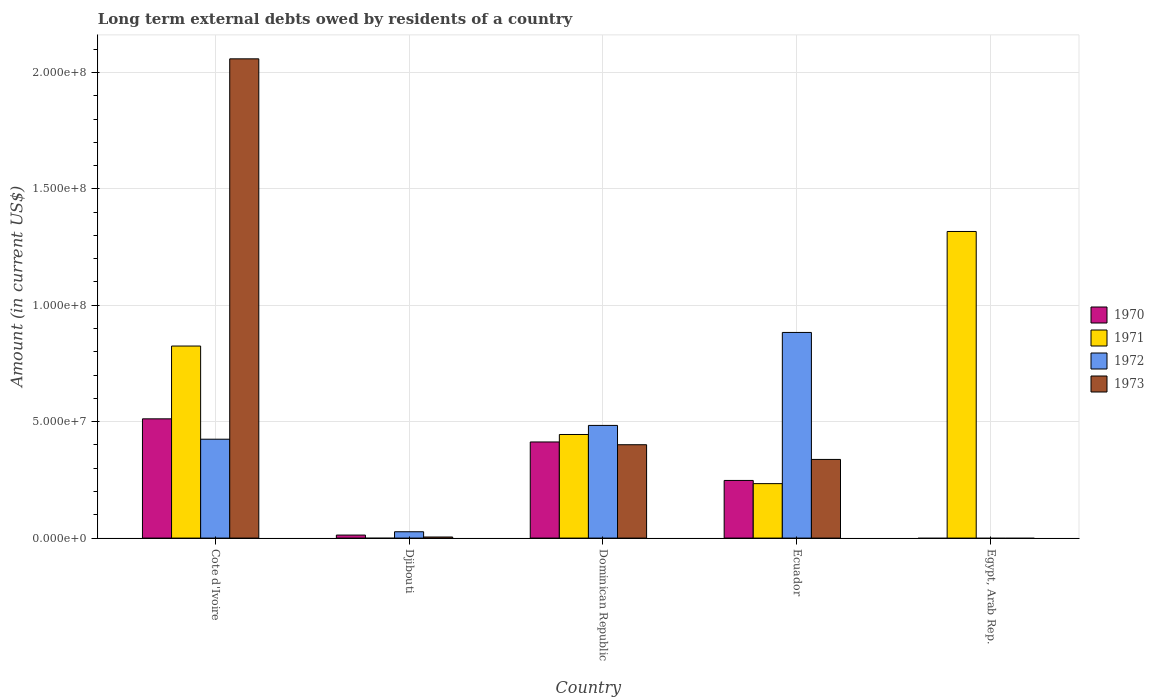Are the number of bars on each tick of the X-axis equal?
Provide a succinct answer. No. How many bars are there on the 4th tick from the left?
Your answer should be compact. 4. How many bars are there on the 5th tick from the right?
Offer a terse response. 4. What is the label of the 4th group of bars from the left?
Your answer should be compact. Ecuador. What is the amount of long-term external debts owed by residents in 1970 in Egypt, Arab Rep.?
Make the answer very short. 0. Across all countries, what is the maximum amount of long-term external debts owed by residents in 1970?
Offer a terse response. 5.12e+07. In which country was the amount of long-term external debts owed by residents in 1971 maximum?
Offer a very short reply. Egypt, Arab Rep. What is the total amount of long-term external debts owed by residents in 1973 in the graph?
Offer a terse response. 2.80e+08. What is the difference between the amount of long-term external debts owed by residents in 1972 in Dominican Republic and that in Ecuador?
Ensure brevity in your answer.  -3.99e+07. What is the difference between the amount of long-term external debts owed by residents in 1973 in Dominican Republic and the amount of long-term external debts owed by residents in 1971 in Cote d'Ivoire?
Ensure brevity in your answer.  -4.24e+07. What is the average amount of long-term external debts owed by residents in 1970 per country?
Offer a very short reply. 2.37e+07. What is the difference between the amount of long-term external debts owed by residents of/in 1970 and amount of long-term external debts owed by residents of/in 1972 in Ecuador?
Make the answer very short. -6.36e+07. In how many countries, is the amount of long-term external debts owed by residents in 1971 greater than 50000000 US$?
Your answer should be compact. 2. What is the ratio of the amount of long-term external debts owed by residents in 1970 in Cote d'Ivoire to that in Dominican Republic?
Keep it short and to the point. 1.24. Is the amount of long-term external debts owed by residents in 1970 in Cote d'Ivoire less than that in Djibouti?
Offer a terse response. No. Is the difference between the amount of long-term external debts owed by residents in 1970 in Djibouti and Ecuador greater than the difference between the amount of long-term external debts owed by residents in 1972 in Djibouti and Ecuador?
Keep it short and to the point. Yes. What is the difference between the highest and the second highest amount of long-term external debts owed by residents in 1970?
Ensure brevity in your answer.  9.93e+06. What is the difference between the highest and the lowest amount of long-term external debts owed by residents in 1973?
Your response must be concise. 2.06e+08. Is the sum of the amount of long-term external debts owed by residents in 1972 in Cote d'Ivoire and Ecuador greater than the maximum amount of long-term external debts owed by residents in 1970 across all countries?
Keep it short and to the point. Yes. Is it the case that in every country, the sum of the amount of long-term external debts owed by residents in 1973 and amount of long-term external debts owed by residents in 1972 is greater than the sum of amount of long-term external debts owed by residents in 1971 and amount of long-term external debts owed by residents in 1970?
Provide a short and direct response. No. What is the difference between two consecutive major ticks on the Y-axis?
Keep it short and to the point. 5.00e+07. Does the graph contain any zero values?
Your response must be concise. Yes. Does the graph contain grids?
Provide a succinct answer. Yes. How are the legend labels stacked?
Offer a terse response. Vertical. What is the title of the graph?
Your answer should be compact. Long term external debts owed by residents of a country. Does "1969" appear as one of the legend labels in the graph?
Your response must be concise. No. What is the label or title of the X-axis?
Your answer should be very brief. Country. What is the Amount (in current US$) of 1970 in Cote d'Ivoire?
Make the answer very short. 5.12e+07. What is the Amount (in current US$) of 1971 in Cote d'Ivoire?
Your response must be concise. 8.25e+07. What is the Amount (in current US$) of 1972 in Cote d'Ivoire?
Your answer should be very brief. 4.25e+07. What is the Amount (in current US$) of 1973 in Cote d'Ivoire?
Provide a short and direct response. 2.06e+08. What is the Amount (in current US$) of 1970 in Djibouti?
Offer a terse response. 1.30e+06. What is the Amount (in current US$) of 1971 in Djibouti?
Give a very brief answer. 0. What is the Amount (in current US$) of 1972 in Djibouti?
Provide a short and direct response. 2.72e+06. What is the Amount (in current US$) in 1973 in Djibouti?
Your answer should be compact. 4.68e+05. What is the Amount (in current US$) in 1970 in Dominican Republic?
Ensure brevity in your answer.  4.13e+07. What is the Amount (in current US$) of 1971 in Dominican Republic?
Your answer should be compact. 4.45e+07. What is the Amount (in current US$) of 1972 in Dominican Republic?
Give a very brief answer. 4.84e+07. What is the Amount (in current US$) of 1973 in Dominican Republic?
Offer a very short reply. 4.01e+07. What is the Amount (in current US$) in 1970 in Ecuador?
Your response must be concise. 2.48e+07. What is the Amount (in current US$) in 1971 in Ecuador?
Make the answer very short. 2.34e+07. What is the Amount (in current US$) in 1972 in Ecuador?
Offer a terse response. 8.83e+07. What is the Amount (in current US$) of 1973 in Ecuador?
Provide a succinct answer. 3.38e+07. What is the Amount (in current US$) in 1971 in Egypt, Arab Rep.?
Offer a terse response. 1.32e+08. What is the Amount (in current US$) in 1972 in Egypt, Arab Rep.?
Provide a succinct answer. 0. What is the Amount (in current US$) of 1973 in Egypt, Arab Rep.?
Give a very brief answer. 0. Across all countries, what is the maximum Amount (in current US$) in 1970?
Provide a short and direct response. 5.12e+07. Across all countries, what is the maximum Amount (in current US$) of 1971?
Make the answer very short. 1.32e+08. Across all countries, what is the maximum Amount (in current US$) in 1972?
Your answer should be very brief. 8.83e+07. Across all countries, what is the maximum Amount (in current US$) in 1973?
Offer a very short reply. 2.06e+08. What is the total Amount (in current US$) in 1970 in the graph?
Ensure brevity in your answer.  1.19e+08. What is the total Amount (in current US$) of 1971 in the graph?
Keep it short and to the point. 2.82e+08. What is the total Amount (in current US$) in 1972 in the graph?
Provide a short and direct response. 1.82e+08. What is the total Amount (in current US$) in 1973 in the graph?
Provide a succinct answer. 2.80e+08. What is the difference between the Amount (in current US$) in 1970 in Cote d'Ivoire and that in Djibouti?
Give a very brief answer. 4.99e+07. What is the difference between the Amount (in current US$) in 1972 in Cote d'Ivoire and that in Djibouti?
Give a very brief answer. 3.98e+07. What is the difference between the Amount (in current US$) of 1973 in Cote d'Ivoire and that in Djibouti?
Your response must be concise. 2.05e+08. What is the difference between the Amount (in current US$) of 1970 in Cote d'Ivoire and that in Dominican Republic?
Offer a very short reply. 9.93e+06. What is the difference between the Amount (in current US$) in 1971 in Cote d'Ivoire and that in Dominican Republic?
Offer a terse response. 3.80e+07. What is the difference between the Amount (in current US$) in 1972 in Cote d'Ivoire and that in Dominican Republic?
Offer a very short reply. -5.92e+06. What is the difference between the Amount (in current US$) of 1973 in Cote d'Ivoire and that in Dominican Republic?
Give a very brief answer. 1.66e+08. What is the difference between the Amount (in current US$) of 1970 in Cote d'Ivoire and that in Ecuador?
Offer a very short reply. 2.65e+07. What is the difference between the Amount (in current US$) of 1971 in Cote d'Ivoire and that in Ecuador?
Your response must be concise. 5.91e+07. What is the difference between the Amount (in current US$) in 1972 in Cote d'Ivoire and that in Ecuador?
Give a very brief answer. -4.59e+07. What is the difference between the Amount (in current US$) in 1973 in Cote d'Ivoire and that in Ecuador?
Give a very brief answer. 1.72e+08. What is the difference between the Amount (in current US$) of 1971 in Cote d'Ivoire and that in Egypt, Arab Rep.?
Provide a succinct answer. -4.92e+07. What is the difference between the Amount (in current US$) of 1970 in Djibouti and that in Dominican Republic?
Your response must be concise. -4.00e+07. What is the difference between the Amount (in current US$) of 1972 in Djibouti and that in Dominican Republic?
Your answer should be compact. -4.57e+07. What is the difference between the Amount (in current US$) of 1973 in Djibouti and that in Dominican Republic?
Offer a terse response. -3.96e+07. What is the difference between the Amount (in current US$) of 1970 in Djibouti and that in Ecuador?
Provide a short and direct response. -2.35e+07. What is the difference between the Amount (in current US$) of 1972 in Djibouti and that in Ecuador?
Make the answer very short. -8.56e+07. What is the difference between the Amount (in current US$) in 1973 in Djibouti and that in Ecuador?
Your answer should be very brief. -3.33e+07. What is the difference between the Amount (in current US$) in 1970 in Dominican Republic and that in Ecuador?
Keep it short and to the point. 1.65e+07. What is the difference between the Amount (in current US$) of 1971 in Dominican Republic and that in Ecuador?
Give a very brief answer. 2.11e+07. What is the difference between the Amount (in current US$) of 1972 in Dominican Republic and that in Ecuador?
Offer a terse response. -3.99e+07. What is the difference between the Amount (in current US$) in 1973 in Dominican Republic and that in Ecuador?
Ensure brevity in your answer.  6.31e+06. What is the difference between the Amount (in current US$) of 1971 in Dominican Republic and that in Egypt, Arab Rep.?
Provide a succinct answer. -8.72e+07. What is the difference between the Amount (in current US$) in 1971 in Ecuador and that in Egypt, Arab Rep.?
Provide a short and direct response. -1.08e+08. What is the difference between the Amount (in current US$) in 1970 in Cote d'Ivoire and the Amount (in current US$) in 1972 in Djibouti?
Your answer should be very brief. 4.85e+07. What is the difference between the Amount (in current US$) of 1970 in Cote d'Ivoire and the Amount (in current US$) of 1973 in Djibouti?
Offer a very short reply. 5.08e+07. What is the difference between the Amount (in current US$) of 1971 in Cote d'Ivoire and the Amount (in current US$) of 1972 in Djibouti?
Your response must be concise. 7.98e+07. What is the difference between the Amount (in current US$) of 1971 in Cote d'Ivoire and the Amount (in current US$) of 1973 in Djibouti?
Offer a terse response. 8.20e+07. What is the difference between the Amount (in current US$) in 1972 in Cote d'Ivoire and the Amount (in current US$) in 1973 in Djibouti?
Offer a very short reply. 4.20e+07. What is the difference between the Amount (in current US$) of 1970 in Cote d'Ivoire and the Amount (in current US$) of 1971 in Dominican Republic?
Give a very brief answer. 6.73e+06. What is the difference between the Amount (in current US$) of 1970 in Cote d'Ivoire and the Amount (in current US$) of 1972 in Dominican Republic?
Keep it short and to the point. 2.83e+06. What is the difference between the Amount (in current US$) in 1970 in Cote d'Ivoire and the Amount (in current US$) in 1973 in Dominican Republic?
Give a very brief answer. 1.11e+07. What is the difference between the Amount (in current US$) in 1971 in Cote d'Ivoire and the Amount (in current US$) in 1972 in Dominican Republic?
Make the answer very short. 3.41e+07. What is the difference between the Amount (in current US$) of 1971 in Cote d'Ivoire and the Amount (in current US$) of 1973 in Dominican Republic?
Ensure brevity in your answer.  4.24e+07. What is the difference between the Amount (in current US$) in 1972 in Cote d'Ivoire and the Amount (in current US$) in 1973 in Dominican Republic?
Offer a very short reply. 2.37e+06. What is the difference between the Amount (in current US$) of 1970 in Cote d'Ivoire and the Amount (in current US$) of 1971 in Ecuador?
Make the answer very short. 2.78e+07. What is the difference between the Amount (in current US$) of 1970 in Cote d'Ivoire and the Amount (in current US$) of 1972 in Ecuador?
Offer a very short reply. -3.71e+07. What is the difference between the Amount (in current US$) of 1970 in Cote d'Ivoire and the Amount (in current US$) of 1973 in Ecuador?
Give a very brief answer. 1.74e+07. What is the difference between the Amount (in current US$) of 1971 in Cote d'Ivoire and the Amount (in current US$) of 1972 in Ecuador?
Provide a short and direct response. -5.84e+06. What is the difference between the Amount (in current US$) in 1971 in Cote d'Ivoire and the Amount (in current US$) in 1973 in Ecuador?
Your answer should be compact. 4.87e+07. What is the difference between the Amount (in current US$) of 1972 in Cote d'Ivoire and the Amount (in current US$) of 1973 in Ecuador?
Offer a very short reply. 8.68e+06. What is the difference between the Amount (in current US$) of 1970 in Cote d'Ivoire and the Amount (in current US$) of 1971 in Egypt, Arab Rep.?
Provide a succinct answer. -8.05e+07. What is the difference between the Amount (in current US$) in 1970 in Djibouti and the Amount (in current US$) in 1971 in Dominican Republic?
Ensure brevity in your answer.  -4.32e+07. What is the difference between the Amount (in current US$) of 1970 in Djibouti and the Amount (in current US$) of 1972 in Dominican Republic?
Your response must be concise. -4.71e+07. What is the difference between the Amount (in current US$) of 1970 in Djibouti and the Amount (in current US$) of 1973 in Dominican Republic?
Keep it short and to the point. -3.88e+07. What is the difference between the Amount (in current US$) in 1972 in Djibouti and the Amount (in current US$) in 1973 in Dominican Republic?
Your answer should be compact. -3.74e+07. What is the difference between the Amount (in current US$) in 1970 in Djibouti and the Amount (in current US$) in 1971 in Ecuador?
Ensure brevity in your answer.  -2.21e+07. What is the difference between the Amount (in current US$) in 1970 in Djibouti and the Amount (in current US$) in 1972 in Ecuador?
Provide a succinct answer. -8.70e+07. What is the difference between the Amount (in current US$) in 1970 in Djibouti and the Amount (in current US$) in 1973 in Ecuador?
Offer a very short reply. -3.25e+07. What is the difference between the Amount (in current US$) of 1972 in Djibouti and the Amount (in current US$) of 1973 in Ecuador?
Make the answer very short. -3.11e+07. What is the difference between the Amount (in current US$) of 1970 in Djibouti and the Amount (in current US$) of 1971 in Egypt, Arab Rep.?
Keep it short and to the point. -1.30e+08. What is the difference between the Amount (in current US$) of 1970 in Dominican Republic and the Amount (in current US$) of 1971 in Ecuador?
Keep it short and to the point. 1.79e+07. What is the difference between the Amount (in current US$) in 1970 in Dominican Republic and the Amount (in current US$) in 1972 in Ecuador?
Provide a succinct answer. -4.70e+07. What is the difference between the Amount (in current US$) of 1970 in Dominican Republic and the Amount (in current US$) of 1973 in Ecuador?
Make the answer very short. 7.50e+06. What is the difference between the Amount (in current US$) in 1971 in Dominican Republic and the Amount (in current US$) in 1972 in Ecuador?
Give a very brief answer. -4.38e+07. What is the difference between the Amount (in current US$) of 1971 in Dominican Republic and the Amount (in current US$) of 1973 in Ecuador?
Offer a very short reply. 1.07e+07. What is the difference between the Amount (in current US$) in 1972 in Dominican Republic and the Amount (in current US$) in 1973 in Ecuador?
Ensure brevity in your answer.  1.46e+07. What is the difference between the Amount (in current US$) in 1970 in Dominican Republic and the Amount (in current US$) in 1971 in Egypt, Arab Rep.?
Provide a succinct answer. -9.04e+07. What is the difference between the Amount (in current US$) in 1970 in Ecuador and the Amount (in current US$) in 1971 in Egypt, Arab Rep.?
Give a very brief answer. -1.07e+08. What is the average Amount (in current US$) in 1970 per country?
Your answer should be very brief. 2.37e+07. What is the average Amount (in current US$) in 1971 per country?
Give a very brief answer. 5.64e+07. What is the average Amount (in current US$) of 1972 per country?
Provide a short and direct response. 3.64e+07. What is the average Amount (in current US$) in 1973 per country?
Give a very brief answer. 5.60e+07. What is the difference between the Amount (in current US$) in 1970 and Amount (in current US$) in 1971 in Cote d'Ivoire?
Make the answer very short. -3.13e+07. What is the difference between the Amount (in current US$) of 1970 and Amount (in current US$) of 1972 in Cote d'Ivoire?
Keep it short and to the point. 8.75e+06. What is the difference between the Amount (in current US$) of 1970 and Amount (in current US$) of 1973 in Cote d'Ivoire?
Provide a short and direct response. -1.55e+08. What is the difference between the Amount (in current US$) in 1971 and Amount (in current US$) in 1972 in Cote d'Ivoire?
Your answer should be compact. 4.00e+07. What is the difference between the Amount (in current US$) of 1971 and Amount (in current US$) of 1973 in Cote d'Ivoire?
Ensure brevity in your answer.  -1.23e+08. What is the difference between the Amount (in current US$) of 1972 and Amount (in current US$) of 1973 in Cote d'Ivoire?
Offer a very short reply. -1.63e+08. What is the difference between the Amount (in current US$) in 1970 and Amount (in current US$) in 1972 in Djibouti?
Keep it short and to the point. -1.42e+06. What is the difference between the Amount (in current US$) in 1970 and Amount (in current US$) in 1973 in Djibouti?
Your answer should be compact. 8.32e+05. What is the difference between the Amount (in current US$) in 1972 and Amount (in current US$) in 1973 in Djibouti?
Keep it short and to the point. 2.26e+06. What is the difference between the Amount (in current US$) in 1970 and Amount (in current US$) in 1971 in Dominican Republic?
Ensure brevity in your answer.  -3.21e+06. What is the difference between the Amount (in current US$) of 1970 and Amount (in current US$) of 1972 in Dominican Republic?
Offer a terse response. -7.11e+06. What is the difference between the Amount (in current US$) of 1970 and Amount (in current US$) of 1973 in Dominican Republic?
Ensure brevity in your answer.  1.19e+06. What is the difference between the Amount (in current US$) of 1971 and Amount (in current US$) of 1972 in Dominican Republic?
Offer a very short reply. -3.90e+06. What is the difference between the Amount (in current US$) of 1971 and Amount (in current US$) of 1973 in Dominican Republic?
Give a very brief answer. 4.39e+06. What is the difference between the Amount (in current US$) of 1972 and Amount (in current US$) of 1973 in Dominican Republic?
Provide a succinct answer. 8.29e+06. What is the difference between the Amount (in current US$) in 1970 and Amount (in current US$) in 1971 in Ecuador?
Your response must be concise. 1.37e+06. What is the difference between the Amount (in current US$) in 1970 and Amount (in current US$) in 1972 in Ecuador?
Offer a very short reply. -6.36e+07. What is the difference between the Amount (in current US$) of 1970 and Amount (in current US$) of 1973 in Ecuador?
Offer a terse response. -9.03e+06. What is the difference between the Amount (in current US$) in 1971 and Amount (in current US$) in 1972 in Ecuador?
Offer a terse response. -6.49e+07. What is the difference between the Amount (in current US$) of 1971 and Amount (in current US$) of 1973 in Ecuador?
Ensure brevity in your answer.  -1.04e+07. What is the difference between the Amount (in current US$) in 1972 and Amount (in current US$) in 1973 in Ecuador?
Your answer should be compact. 5.45e+07. What is the ratio of the Amount (in current US$) in 1970 in Cote d'Ivoire to that in Djibouti?
Your answer should be compact. 39.4. What is the ratio of the Amount (in current US$) in 1972 in Cote d'Ivoire to that in Djibouti?
Your response must be concise. 15.6. What is the ratio of the Amount (in current US$) in 1973 in Cote d'Ivoire to that in Djibouti?
Your response must be concise. 439.86. What is the ratio of the Amount (in current US$) in 1970 in Cote d'Ivoire to that in Dominican Republic?
Your answer should be compact. 1.24. What is the ratio of the Amount (in current US$) of 1971 in Cote d'Ivoire to that in Dominican Republic?
Ensure brevity in your answer.  1.85. What is the ratio of the Amount (in current US$) of 1972 in Cote d'Ivoire to that in Dominican Republic?
Offer a very short reply. 0.88. What is the ratio of the Amount (in current US$) in 1973 in Cote d'Ivoire to that in Dominican Republic?
Make the answer very short. 5.13. What is the ratio of the Amount (in current US$) in 1970 in Cote d'Ivoire to that in Ecuador?
Keep it short and to the point. 2.07. What is the ratio of the Amount (in current US$) in 1971 in Cote d'Ivoire to that in Ecuador?
Make the answer very short. 3.53. What is the ratio of the Amount (in current US$) of 1972 in Cote d'Ivoire to that in Ecuador?
Keep it short and to the point. 0.48. What is the ratio of the Amount (in current US$) of 1973 in Cote d'Ivoire to that in Ecuador?
Your answer should be very brief. 6.09. What is the ratio of the Amount (in current US$) of 1971 in Cote d'Ivoire to that in Egypt, Arab Rep.?
Your response must be concise. 0.63. What is the ratio of the Amount (in current US$) in 1970 in Djibouti to that in Dominican Republic?
Your response must be concise. 0.03. What is the ratio of the Amount (in current US$) in 1972 in Djibouti to that in Dominican Republic?
Ensure brevity in your answer.  0.06. What is the ratio of the Amount (in current US$) in 1973 in Djibouti to that in Dominican Republic?
Provide a succinct answer. 0.01. What is the ratio of the Amount (in current US$) in 1970 in Djibouti to that in Ecuador?
Offer a terse response. 0.05. What is the ratio of the Amount (in current US$) in 1972 in Djibouti to that in Ecuador?
Your answer should be very brief. 0.03. What is the ratio of the Amount (in current US$) of 1973 in Djibouti to that in Ecuador?
Offer a very short reply. 0.01. What is the ratio of the Amount (in current US$) in 1970 in Dominican Republic to that in Ecuador?
Offer a terse response. 1.67. What is the ratio of the Amount (in current US$) in 1971 in Dominican Republic to that in Ecuador?
Keep it short and to the point. 1.9. What is the ratio of the Amount (in current US$) of 1972 in Dominican Republic to that in Ecuador?
Your answer should be compact. 0.55. What is the ratio of the Amount (in current US$) in 1973 in Dominican Republic to that in Ecuador?
Your answer should be very brief. 1.19. What is the ratio of the Amount (in current US$) of 1971 in Dominican Republic to that in Egypt, Arab Rep.?
Give a very brief answer. 0.34. What is the ratio of the Amount (in current US$) in 1971 in Ecuador to that in Egypt, Arab Rep.?
Your answer should be compact. 0.18. What is the difference between the highest and the second highest Amount (in current US$) of 1970?
Provide a succinct answer. 9.93e+06. What is the difference between the highest and the second highest Amount (in current US$) in 1971?
Provide a short and direct response. 4.92e+07. What is the difference between the highest and the second highest Amount (in current US$) of 1972?
Ensure brevity in your answer.  3.99e+07. What is the difference between the highest and the second highest Amount (in current US$) of 1973?
Ensure brevity in your answer.  1.66e+08. What is the difference between the highest and the lowest Amount (in current US$) in 1970?
Your response must be concise. 5.12e+07. What is the difference between the highest and the lowest Amount (in current US$) in 1971?
Your answer should be very brief. 1.32e+08. What is the difference between the highest and the lowest Amount (in current US$) in 1972?
Provide a succinct answer. 8.83e+07. What is the difference between the highest and the lowest Amount (in current US$) in 1973?
Give a very brief answer. 2.06e+08. 